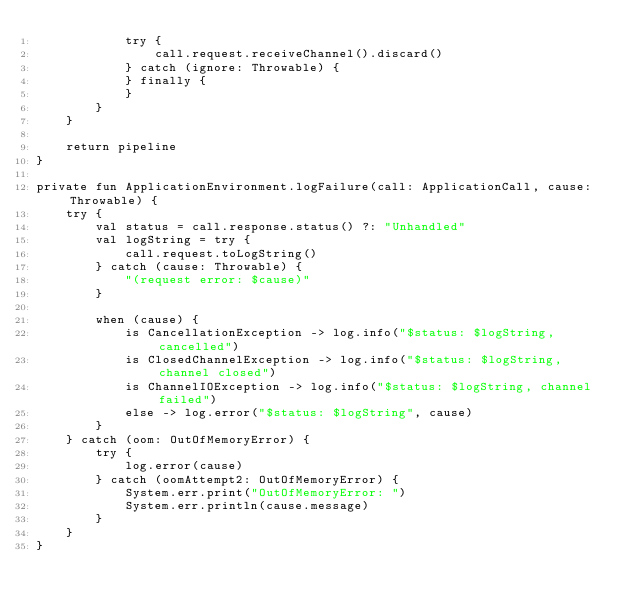<code> <loc_0><loc_0><loc_500><loc_500><_Kotlin_>            try {
                call.request.receiveChannel().discard()
            } catch (ignore: Throwable) {
            } finally {
            }
        }
    }

    return pipeline
}

private fun ApplicationEnvironment.logFailure(call: ApplicationCall, cause: Throwable) {
    try {
        val status = call.response.status() ?: "Unhandled"
        val logString = try {
            call.request.toLogString()
        } catch (cause: Throwable) {
            "(request error: $cause)"
        }

        when (cause) {
            is CancellationException -> log.info("$status: $logString, cancelled")
            is ClosedChannelException -> log.info("$status: $logString, channel closed")
            is ChannelIOException -> log.info("$status: $logString, channel failed")
            else -> log.error("$status: $logString", cause)
        }
    } catch (oom: OutOfMemoryError) {
        try {
            log.error(cause)
        } catch (oomAttempt2: OutOfMemoryError) {
            System.err.print("OutOfMemoryError: ")
            System.err.println(cause.message)
        }
    }
}
</code> 